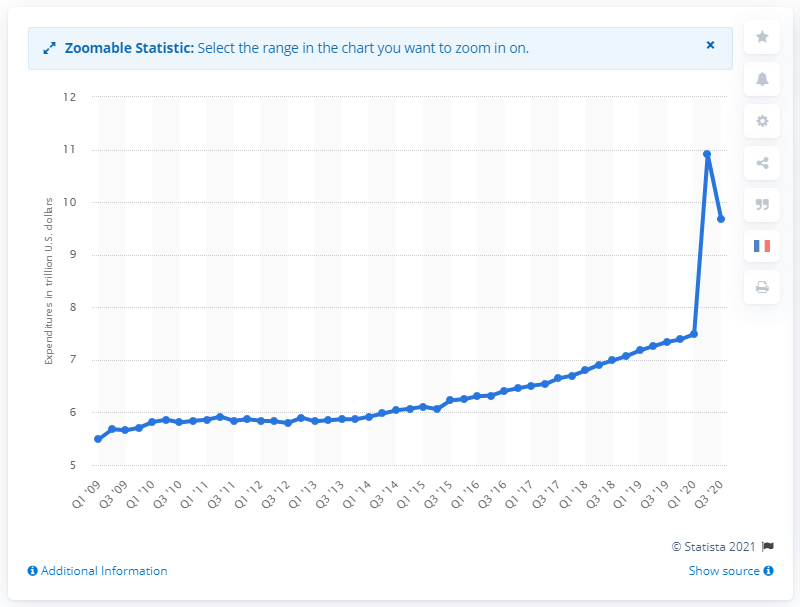Specify some key components in this picture. The government expenditure in the first quarter of 2009 was 5.49. In the third quarter of 2020, the annual government expenditure in the United States was approximately 9.68. 